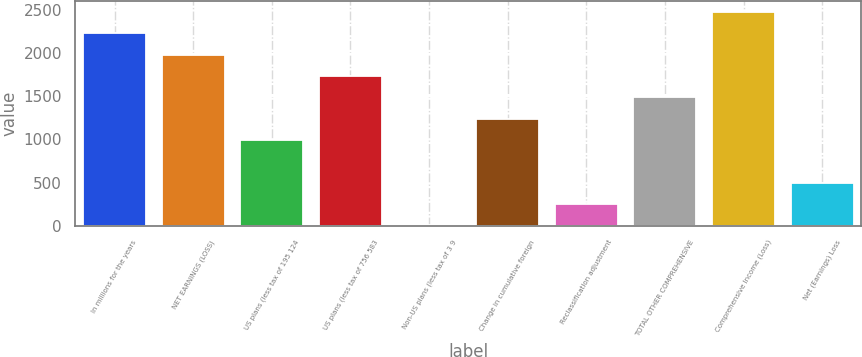<chart> <loc_0><loc_0><loc_500><loc_500><bar_chart><fcel>In millions for the years<fcel>NET EARNINGS (LOSS)<fcel>US plans (less tax of 195 124<fcel>US plans (less tax of 756 583<fcel>Non-US plans (less tax of 3 9<fcel>Change in cumulative foreign<fcel>Reclassification adjustment<fcel>TOTAL OTHER COMPREHENSIVE<fcel>Comprehensive Income (Loss)<fcel>Net (Earnings) Loss<nl><fcel>2228.8<fcel>1981.6<fcel>992.8<fcel>1734.4<fcel>4<fcel>1240<fcel>251.2<fcel>1487.2<fcel>2476<fcel>498.4<nl></chart> 